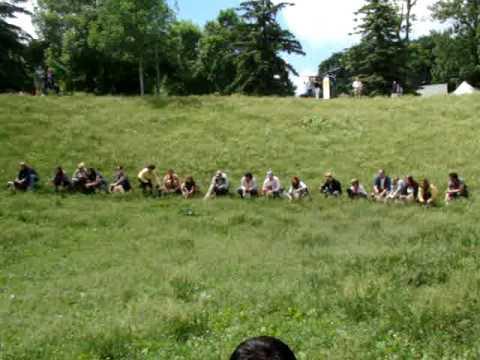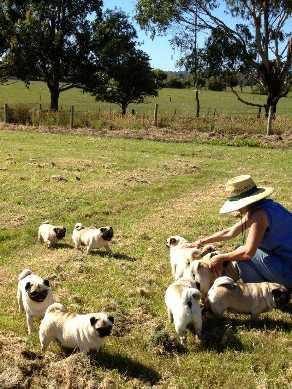The first image is the image on the left, the second image is the image on the right. Given the left and right images, does the statement "An image shows exactly one pug dog, which is facing another living creature that is not a pug." hold true? Answer yes or no. No. The first image is the image on the left, the second image is the image on the right. Assess this claim about the two images: "At least one person is with the dogs outside in one of the images.". Correct or not? Answer yes or no. Yes. 